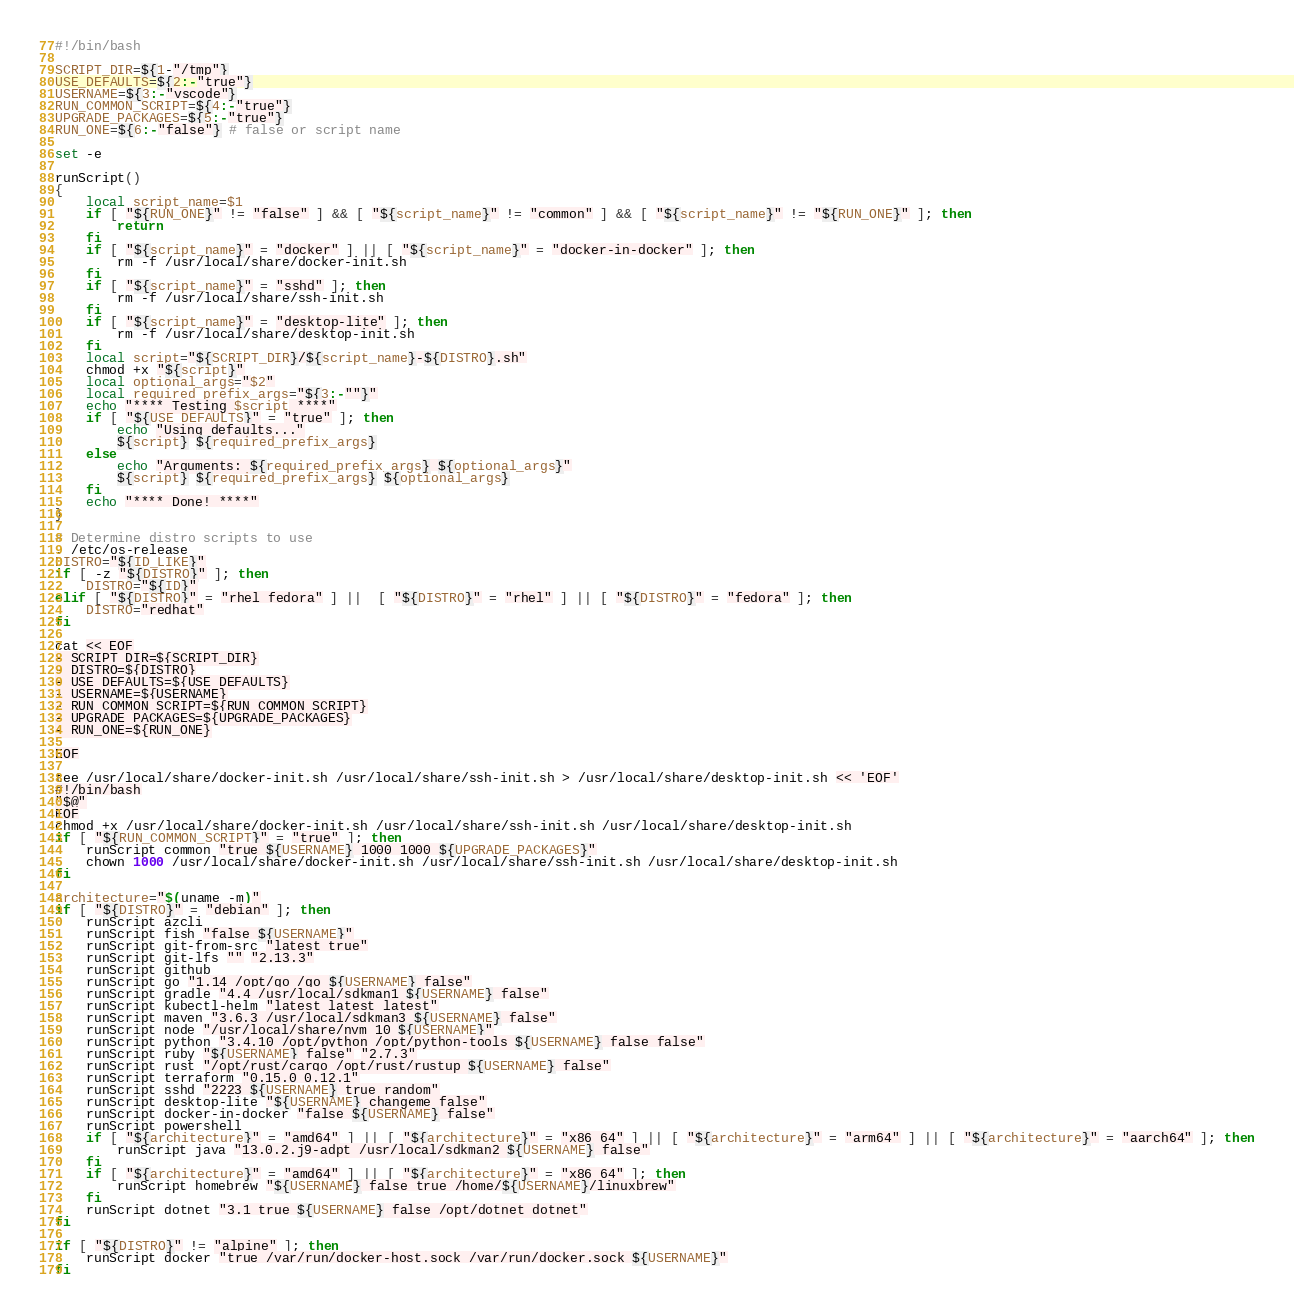<code> <loc_0><loc_0><loc_500><loc_500><_Bash_>#!/bin/bash

SCRIPT_DIR=${1-"/tmp"}
USE_DEFAULTS=${2:-"true"}
USERNAME=${3:-"vscode"}
RUN_COMMON_SCRIPT=${4:-"true"}
UPGRADE_PACKAGES=${5:-"true"}
RUN_ONE=${6:-"false"} # false or script name

set -e

runScript()
{
    local script_name=$1
    if [ "${RUN_ONE}" != "false" ] && [ "${script_name}" != "common" ] && [ "${script_name}" != "${RUN_ONE}" ]; then
        return
    fi
    if [ "${script_name}" = "docker" ] || [ "${script_name}" = "docker-in-docker" ]; then
        rm -f /usr/local/share/docker-init.sh
    fi
    if [ "${script_name}" = "sshd" ]; then
        rm -f /usr/local/share/ssh-init.sh
    fi
    if [ "${script_name}" = "desktop-lite" ]; then
        rm -f /usr/local/share/desktop-init.sh
    fi
    local script="${SCRIPT_DIR}/${script_name}-${DISTRO}.sh"
    chmod +x "${script}"
    local optional_args="$2"
    local required_prefix_args="${3:-""}"
    echo "**** Testing $script ****"
    if [ "${USE_DEFAULTS}" = "true" ]; then
        echo "Using defaults..."
        ${script} ${required_prefix_args}
    else
        echo "Arguments: ${required_prefix_args} ${optional_args}"
        ${script} ${required_prefix_args} ${optional_args}
    fi
    echo "**** Done! ****"
}

# Determine distro scripts to use
. /etc/os-release
DISTRO="${ID_LIKE}"
if [ -z "${DISTRO}" ]; then
    DISTRO="${ID}"
elif [ "${DISTRO}" = "rhel fedora" ] ||  [ "${DISTRO}" = "rhel" ] || [ "${DISTRO}" = "fedora" ]; then
    DISTRO="redhat"
fi

cat << EOF
- SCRIPT_DIR=${SCRIPT_DIR}
- DISTRO=${DISTRO}
- USE_DEFAULTS=${USE_DEFAULTS}
- USERNAME=${USERNAME}
- RUN_COMMON_SCRIPT=${RUN_COMMON_SCRIPT}
- UPGRADE_PACKAGES=${UPGRADE_PACKAGES}
- RUN_ONE=${RUN_ONE}

EOF

tee /usr/local/share/docker-init.sh /usr/local/share/ssh-init.sh > /usr/local/share/desktop-init.sh << 'EOF'
#!/bin/bash
"$@"
EOF
chmod +x /usr/local/share/docker-init.sh /usr/local/share/ssh-init.sh /usr/local/share/desktop-init.sh
if [ "${RUN_COMMON_SCRIPT}" = "true" ]; then
    runScript common "true ${USERNAME} 1000 1000 ${UPGRADE_PACKAGES}"
    chown 1000 /usr/local/share/docker-init.sh /usr/local/share/ssh-init.sh /usr/local/share/desktop-init.sh
fi

architecture="$(uname -m)"
if [ "${DISTRO}" = "debian" ]; then
    runScript azcli
    runScript fish "false ${USERNAME}"
    runScript git-from-src "latest true"
    runScript git-lfs "" "2.13.3"
    runScript github
    runScript go "1.14 /opt/go /go ${USERNAME} false"
    runScript gradle "4.4 /usr/local/sdkman1 ${USERNAME} false"
    runScript kubectl-helm "latest latest latest"
    runScript maven "3.6.3 /usr/local/sdkman3 ${USERNAME} false" 
    runScript node "/usr/local/share/nvm 10 ${USERNAME}"
    runScript python "3.4.10 /opt/python /opt/python-tools ${USERNAME} false false"
    runScript ruby "${USERNAME} false" "2.7.3"
    runScript rust "/opt/rust/cargo /opt/rust/rustup ${USERNAME} false"
    runScript terraform "0.15.0 0.12.1"
    runScript sshd "2223 ${USERNAME} true random"
    runScript desktop-lite "${USERNAME} changeme false"
    runScript docker-in-docker "false ${USERNAME} false"
    runScript powershell
    if [ "${architecture}" = "amd64" ] || [ "${architecture}" = "x86_64" ] || [ "${architecture}" = "arm64" ] || [ "${architecture}" = "aarch64" ]; then
        runScript java "13.0.2.j9-adpt /usr/local/sdkman2 ${USERNAME} false"
    fi
    if [ "${architecture}" = "amd64" ] || [ "${architecture}" = "x86_64" ]; then
        runScript homebrew "${USERNAME} false true /home/${USERNAME}/linuxbrew"
    fi
    runScript dotnet "3.1 true ${USERNAME} false /opt/dotnet dotnet" 
fi

if [ "${DISTRO}" != "alpine" ]; then
    runScript docker "true /var/run/docker-host.sock /var/run/docker.sock ${USERNAME}"
fi
</code> 